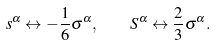Convert formula to latex. <formula><loc_0><loc_0><loc_500><loc_500>s ^ { \alpha } \leftrightarrow - \frac { 1 } { 6 } \sigma ^ { \alpha } , \quad S ^ { \alpha } \leftrightarrow \frac { 2 } { 3 } \sigma ^ { \alpha } .</formula> 